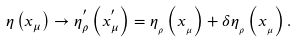Convert formula to latex. <formula><loc_0><loc_0><loc_500><loc_500>\eta \left ( x _ { \mu } \right ) \rightarrow \eta _ { \rho } ^ { ^ { \prime } } \left ( x _ { \mu } ^ { ^ { \prime } } \right ) = \eta _ { _ { \rho } } \left ( x _ { _ { \mu } } \right ) + \delta \eta _ { _ { \rho } } \left ( x _ { _ { \mu } } \right ) .</formula> 